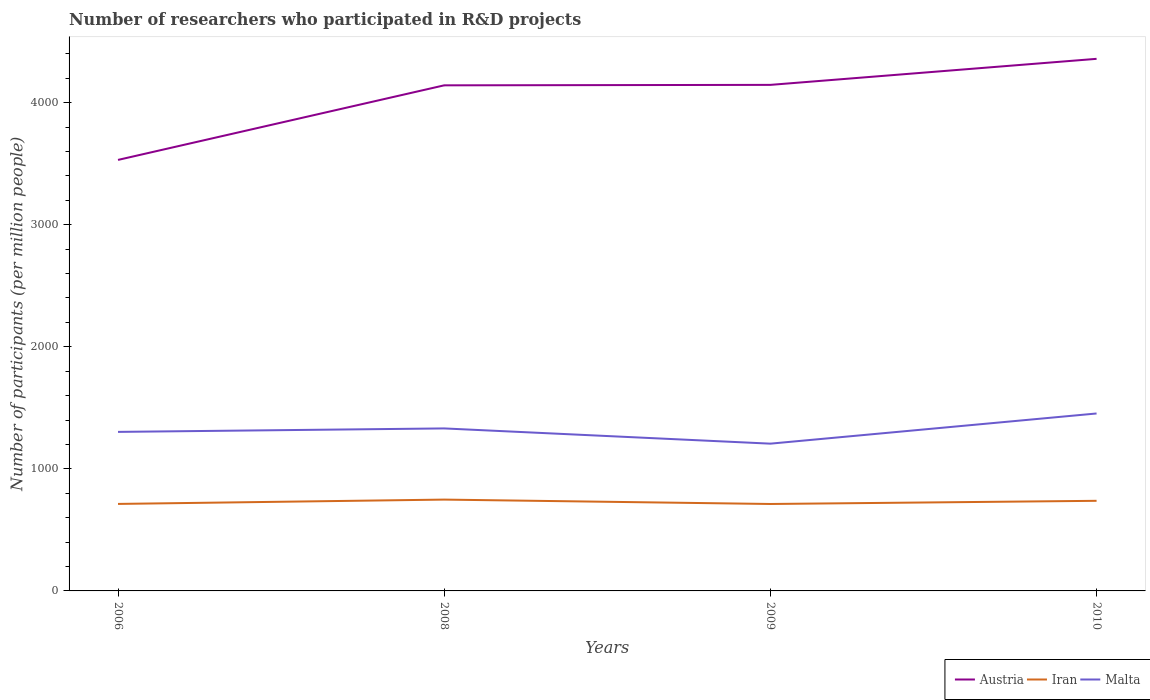Does the line corresponding to Malta intersect with the line corresponding to Iran?
Your answer should be very brief. No. Across all years, what is the maximum number of researchers who participated in R&D projects in Iran?
Offer a very short reply. 712.22. In which year was the number of researchers who participated in R&D projects in Malta maximum?
Make the answer very short. 2009. What is the total number of researchers who participated in R&D projects in Iran in the graph?
Offer a terse response. -35.52. What is the difference between the highest and the second highest number of researchers who participated in R&D projects in Malta?
Provide a short and direct response. 247.23. What is the difference between the highest and the lowest number of researchers who participated in R&D projects in Austria?
Keep it short and to the point. 3. How many lines are there?
Offer a very short reply. 3. Are the values on the major ticks of Y-axis written in scientific E-notation?
Offer a very short reply. No. How are the legend labels stacked?
Keep it short and to the point. Horizontal. What is the title of the graph?
Offer a very short reply. Number of researchers who participated in R&D projects. Does "Kazakhstan" appear as one of the legend labels in the graph?
Keep it short and to the point. No. What is the label or title of the Y-axis?
Offer a very short reply. Number of participants (per million people). What is the Number of participants (per million people) in Austria in 2006?
Give a very brief answer. 3530.95. What is the Number of participants (per million people) in Iran in 2006?
Offer a very short reply. 712.69. What is the Number of participants (per million people) of Malta in 2006?
Give a very brief answer. 1302.85. What is the Number of participants (per million people) of Austria in 2008?
Offer a terse response. 4141.92. What is the Number of participants (per million people) in Iran in 2008?
Provide a succinct answer. 748.21. What is the Number of participants (per million people) in Malta in 2008?
Make the answer very short. 1331.23. What is the Number of participants (per million people) of Austria in 2009?
Your response must be concise. 4145.7. What is the Number of participants (per million people) of Iran in 2009?
Keep it short and to the point. 712.22. What is the Number of participants (per million people) in Malta in 2009?
Ensure brevity in your answer.  1206.42. What is the Number of participants (per million people) in Austria in 2010?
Your response must be concise. 4359.03. What is the Number of participants (per million people) of Iran in 2010?
Keep it short and to the point. 738.19. What is the Number of participants (per million people) of Malta in 2010?
Ensure brevity in your answer.  1453.66. Across all years, what is the maximum Number of participants (per million people) in Austria?
Ensure brevity in your answer.  4359.03. Across all years, what is the maximum Number of participants (per million people) of Iran?
Your response must be concise. 748.21. Across all years, what is the maximum Number of participants (per million people) in Malta?
Provide a short and direct response. 1453.66. Across all years, what is the minimum Number of participants (per million people) of Austria?
Provide a succinct answer. 3530.95. Across all years, what is the minimum Number of participants (per million people) of Iran?
Provide a short and direct response. 712.22. Across all years, what is the minimum Number of participants (per million people) of Malta?
Make the answer very short. 1206.42. What is the total Number of participants (per million people) of Austria in the graph?
Offer a very short reply. 1.62e+04. What is the total Number of participants (per million people) in Iran in the graph?
Your answer should be compact. 2911.3. What is the total Number of participants (per million people) of Malta in the graph?
Provide a short and direct response. 5294.16. What is the difference between the Number of participants (per million people) in Austria in 2006 and that in 2008?
Offer a very short reply. -610.98. What is the difference between the Number of participants (per million people) in Iran in 2006 and that in 2008?
Make the answer very short. -35.52. What is the difference between the Number of participants (per million people) in Malta in 2006 and that in 2008?
Provide a short and direct response. -28.38. What is the difference between the Number of participants (per million people) in Austria in 2006 and that in 2009?
Provide a succinct answer. -614.75. What is the difference between the Number of participants (per million people) in Iran in 2006 and that in 2009?
Provide a succinct answer. 0.47. What is the difference between the Number of participants (per million people) of Malta in 2006 and that in 2009?
Your response must be concise. 96.43. What is the difference between the Number of participants (per million people) of Austria in 2006 and that in 2010?
Make the answer very short. -828.08. What is the difference between the Number of participants (per million people) in Iran in 2006 and that in 2010?
Provide a short and direct response. -25.5. What is the difference between the Number of participants (per million people) in Malta in 2006 and that in 2010?
Make the answer very short. -150.81. What is the difference between the Number of participants (per million people) in Austria in 2008 and that in 2009?
Your answer should be very brief. -3.78. What is the difference between the Number of participants (per million people) in Iran in 2008 and that in 2009?
Provide a succinct answer. 35.99. What is the difference between the Number of participants (per million people) in Malta in 2008 and that in 2009?
Offer a very short reply. 124.8. What is the difference between the Number of participants (per million people) in Austria in 2008 and that in 2010?
Give a very brief answer. -217.1. What is the difference between the Number of participants (per million people) of Iran in 2008 and that in 2010?
Keep it short and to the point. 10.02. What is the difference between the Number of participants (per million people) of Malta in 2008 and that in 2010?
Ensure brevity in your answer.  -122.43. What is the difference between the Number of participants (per million people) of Austria in 2009 and that in 2010?
Provide a succinct answer. -213.33. What is the difference between the Number of participants (per million people) of Iran in 2009 and that in 2010?
Make the answer very short. -25.97. What is the difference between the Number of participants (per million people) of Malta in 2009 and that in 2010?
Your answer should be very brief. -247.23. What is the difference between the Number of participants (per million people) in Austria in 2006 and the Number of participants (per million people) in Iran in 2008?
Give a very brief answer. 2782.74. What is the difference between the Number of participants (per million people) of Austria in 2006 and the Number of participants (per million people) of Malta in 2008?
Your answer should be compact. 2199.72. What is the difference between the Number of participants (per million people) in Iran in 2006 and the Number of participants (per million people) in Malta in 2008?
Your answer should be very brief. -618.54. What is the difference between the Number of participants (per million people) of Austria in 2006 and the Number of participants (per million people) of Iran in 2009?
Offer a terse response. 2818.73. What is the difference between the Number of participants (per million people) in Austria in 2006 and the Number of participants (per million people) in Malta in 2009?
Your answer should be compact. 2324.52. What is the difference between the Number of participants (per million people) in Iran in 2006 and the Number of participants (per million people) in Malta in 2009?
Your answer should be compact. -493.74. What is the difference between the Number of participants (per million people) in Austria in 2006 and the Number of participants (per million people) in Iran in 2010?
Provide a succinct answer. 2792.76. What is the difference between the Number of participants (per million people) in Austria in 2006 and the Number of participants (per million people) in Malta in 2010?
Offer a very short reply. 2077.29. What is the difference between the Number of participants (per million people) in Iran in 2006 and the Number of participants (per million people) in Malta in 2010?
Your answer should be compact. -740.97. What is the difference between the Number of participants (per million people) of Austria in 2008 and the Number of participants (per million people) of Iran in 2009?
Offer a terse response. 3429.71. What is the difference between the Number of participants (per million people) of Austria in 2008 and the Number of participants (per million people) of Malta in 2009?
Your answer should be compact. 2935.5. What is the difference between the Number of participants (per million people) in Iran in 2008 and the Number of participants (per million people) in Malta in 2009?
Provide a succinct answer. -458.22. What is the difference between the Number of participants (per million people) in Austria in 2008 and the Number of participants (per million people) in Iran in 2010?
Offer a terse response. 3403.74. What is the difference between the Number of participants (per million people) in Austria in 2008 and the Number of participants (per million people) in Malta in 2010?
Give a very brief answer. 2688.27. What is the difference between the Number of participants (per million people) of Iran in 2008 and the Number of participants (per million people) of Malta in 2010?
Provide a succinct answer. -705.45. What is the difference between the Number of participants (per million people) in Austria in 2009 and the Number of participants (per million people) in Iran in 2010?
Offer a terse response. 3407.51. What is the difference between the Number of participants (per million people) in Austria in 2009 and the Number of participants (per million people) in Malta in 2010?
Offer a terse response. 2692.04. What is the difference between the Number of participants (per million people) in Iran in 2009 and the Number of participants (per million people) in Malta in 2010?
Give a very brief answer. -741.44. What is the average Number of participants (per million people) of Austria per year?
Provide a succinct answer. 4044.4. What is the average Number of participants (per million people) in Iran per year?
Your answer should be very brief. 727.82. What is the average Number of participants (per million people) of Malta per year?
Offer a very short reply. 1323.54. In the year 2006, what is the difference between the Number of participants (per million people) of Austria and Number of participants (per million people) of Iran?
Ensure brevity in your answer.  2818.26. In the year 2006, what is the difference between the Number of participants (per million people) in Austria and Number of participants (per million people) in Malta?
Give a very brief answer. 2228.09. In the year 2006, what is the difference between the Number of participants (per million people) of Iran and Number of participants (per million people) of Malta?
Your answer should be very brief. -590.16. In the year 2008, what is the difference between the Number of participants (per million people) of Austria and Number of participants (per million people) of Iran?
Provide a short and direct response. 3393.72. In the year 2008, what is the difference between the Number of participants (per million people) of Austria and Number of participants (per million people) of Malta?
Provide a short and direct response. 2810.7. In the year 2008, what is the difference between the Number of participants (per million people) of Iran and Number of participants (per million people) of Malta?
Your response must be concise. -583.02. In the year 2009, what is the difference between the Number of participants (per million people) in Austria and Number of participants (per million people) in Iran?
Give a very brief answer. 3433.48. In the year 2009, what is the difference between the Number of participants (per million people) in Austria and Number of participants (per million people) in Malta?
Give a very brief answer. 2939.28. In the year 2009, what is the difference between the Number of participants (per million people) of Iran and Number of participants (per million people) of Malta?
Provide a short and direct response. -494.21. In the year 2010, what is the difference between the Number of participants (per million people) in Austria and Number of participants (per million people) in Iran?
Your response must be concise. 3620.84. In the year 2010, what is the difference between the Number of participants (per million people) in Austria and Number of participants (per million people) in Malta?
Ensure brevity in your answer.  2905.37. In the year 2010, what is the difference between the Number of participants (per million people) of Iran and Number of participants (per million people) of Malta?
Keep it short and to the point. -715.47. What is the ratio of the Number of participants (per million people) of Austria in 2006 to that in 2008?
Your answer should be very brief. 0.85. What is the ratio of the Number of participants (per million people) of Iran in 2006 to that in 2008?
Offer a terse response. 0.95. What is the ratio of the Number of participants (per million people) in Malta in 2006 to that in 2008?
Your answer should be compact. 0.98. What is the ratio of the Number of participants (per million people) of Austria in 2006 to that in 2009?
Offer a very short reply. 0.85. What is the ratio of the Number of participants (per million people) of Malta in 2006 to that in 2009?
Keep it short and to the point. 1.08. What is the ratio of the Number of participants (per million people) of Austria in 2006 to that in 2010?
Your answer should be very brief. 0.81. What is the ratio of the Number of participants (per million people) in Iran in 2006 to that in 2010?
Offer a terse response. 0.97. What is the ratio of the Number of participants (per million people) of Malta in 2006 to that in 2010?
Ensure brevity in your answer.  0.9. What is the ratio of the Number of participants (per million people) in Austria in 2008 to that in 2009?
Make the answer very short. 1. What is the ratio of the Number of participants (per million people) of Iran in 2008 to that in 2009?
Give a very brief answer. 1.05. What is the ratio of the Number of participants (per million people) of Malta in 2008 to that in 2009?
Provide a succinct answer. 1.1. What is the ratio of the Number of participants (per million people) of Austria in 2008 to that in 2010?
Your answer should be very brief. 0.95. What is the ratio of the Number of participants (per million people) in Iran in 2008 to that in 2010?
Your answer should be very brief. 1.01. What is the ratio of the Number of participants (per million people) of Malta in 2008 to that in 2010?
Provide a short and direct response. 0.92. What is the ratio of the Number of participants (per million people) of Austria in 2009 to that in 2010?
Provide a short and direct response. 0.95. What is the ratio of the Number of participants (per million people) of Iran in 2009 to that in 2010?
Give a very brief answer. 0.96. What is the ratio of the Number of participants (per million people) in Malta in 2009 to that in 2010?
Keep it short and to the point. 0.83. What is the difference between the highest and the second highest Number of participants (per million people) in Austria?
Provide a short and direct response. 213.33. What is the difference between the highest and the second highest Number of participants (per million people) in Iran?
Your answer should be very brief. 10.02. What is the difference between the highest and the second highest Number of participants (per million people) in Malta?
Your response must be concise. 122.43. What is the difference between the highest and the lowest Number of participants (per million people) of Austria?
Offer a terse response. 828.08. What is the difference between the highest and the lowest Number of participants (per million people) in Iran?
Keep it short and to the point. 35.99. What is the difference between the highest and the lowest Number of participants (per million people) of Malta?
Your answer should be very brief. 247.23. 